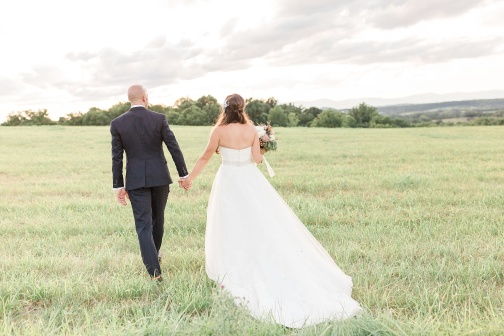Imagine this scene is part of a movie. What genre would it be and why? This scene would likely be from a romantic drama. The imagery of a couple in wedding attire, walking hand in hand through a serene, lush field against a picturesque sky, evokes emotions of love, hope, and the beginning of a transformative journey. The setting and context are ideal for a story that explores the depth of relationships and the emotional landscapes they traverse. 